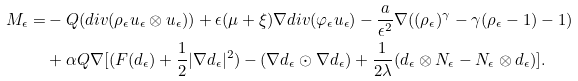<formula> <loc_0><loc_0><loc_500><loc_500>M _ { \epsilon } = & - Q ( d i v ( \rho _ { \epsilon } u _ { \epsilon } \otimes u _ { \epsilon } ) ) + \epsilon ( \mu + \xi ) \nabla d i v ( \varphi _ { \epsilon } u _ { \epsilon } ) - \frac { a } { { \epsilon } ^ { 2 } } \nabla ( ( \rho _ { \epsilon } ) ^ { \gamma } - \gamma ( \rho _ { \epsilon } - 1 ) - 1 ) \\ & + \alpha Q \nabla [ ( F ( d _ { \epsilon } ) + \frac { 1 } { 2 } | \nabla d _ { \epsilon } | ^ { 2 } ) - ( \nabla d _ { \epsilon } \odot \nabla d _ { \epsilon } ) + \frac { 1 } { 2 \lambda } ( d _ { \epsilon } \otimes N _ { \epsilon } - N _ { \epsilon } \otimes d _ { \epsilon } ) ] .</formula> 